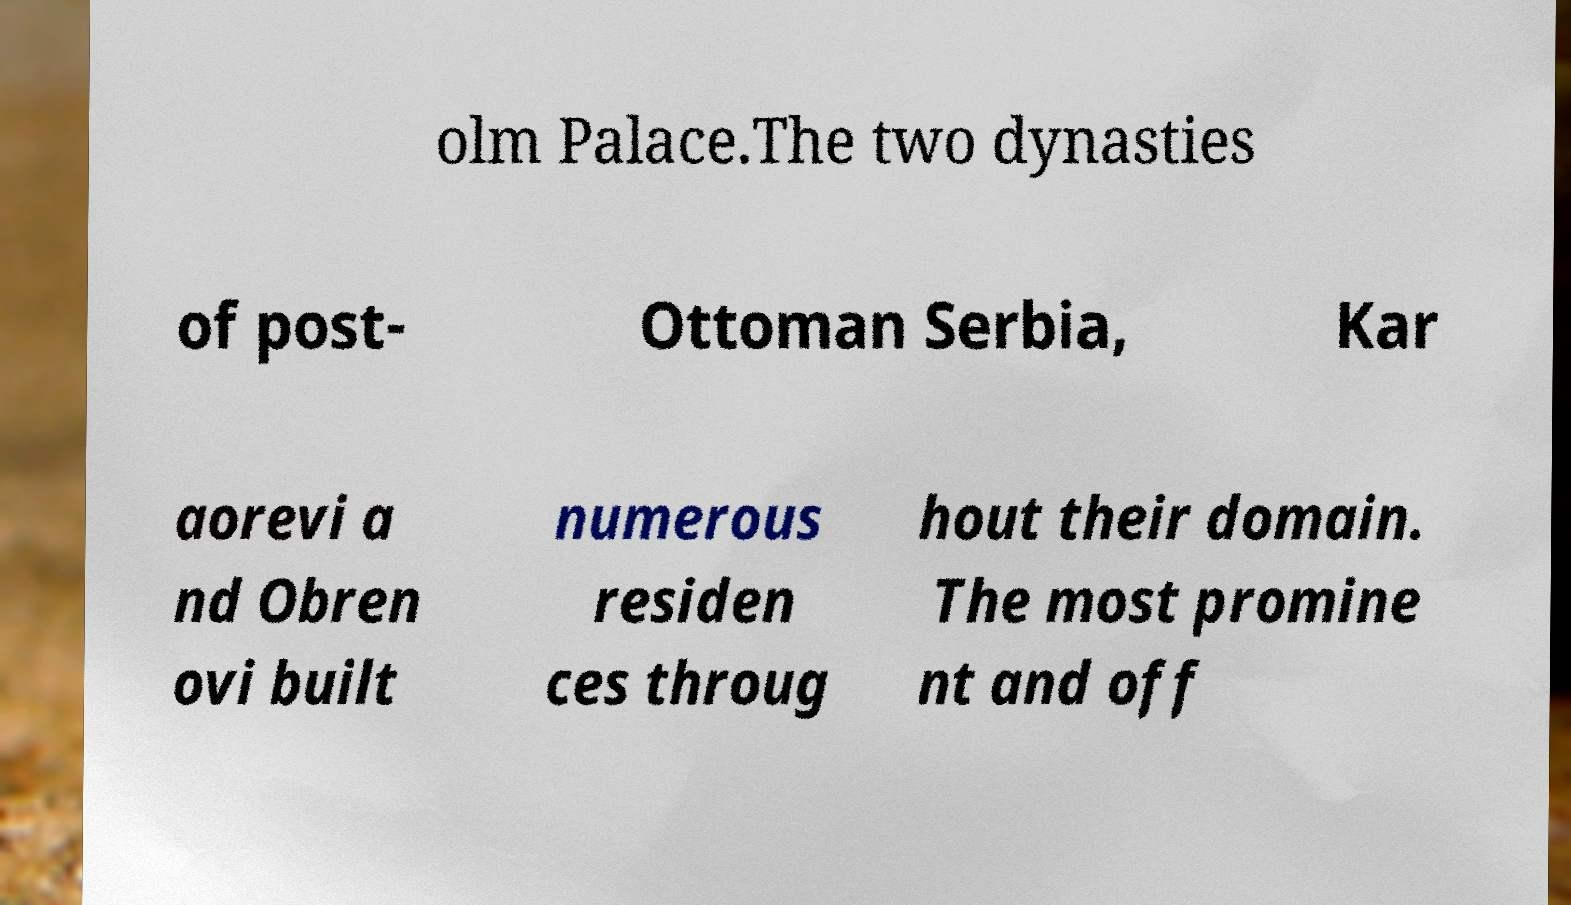Can you read and provide the text displayed in the image?This photo seems to have some interesting text. Can you extract and type it out for me? olm Palace.The two dynasties of post- Ottoman Serbia, Kar aorevi a nd Obren ovi built numerous residen ces throug hout their domain. The most promine nt and off 